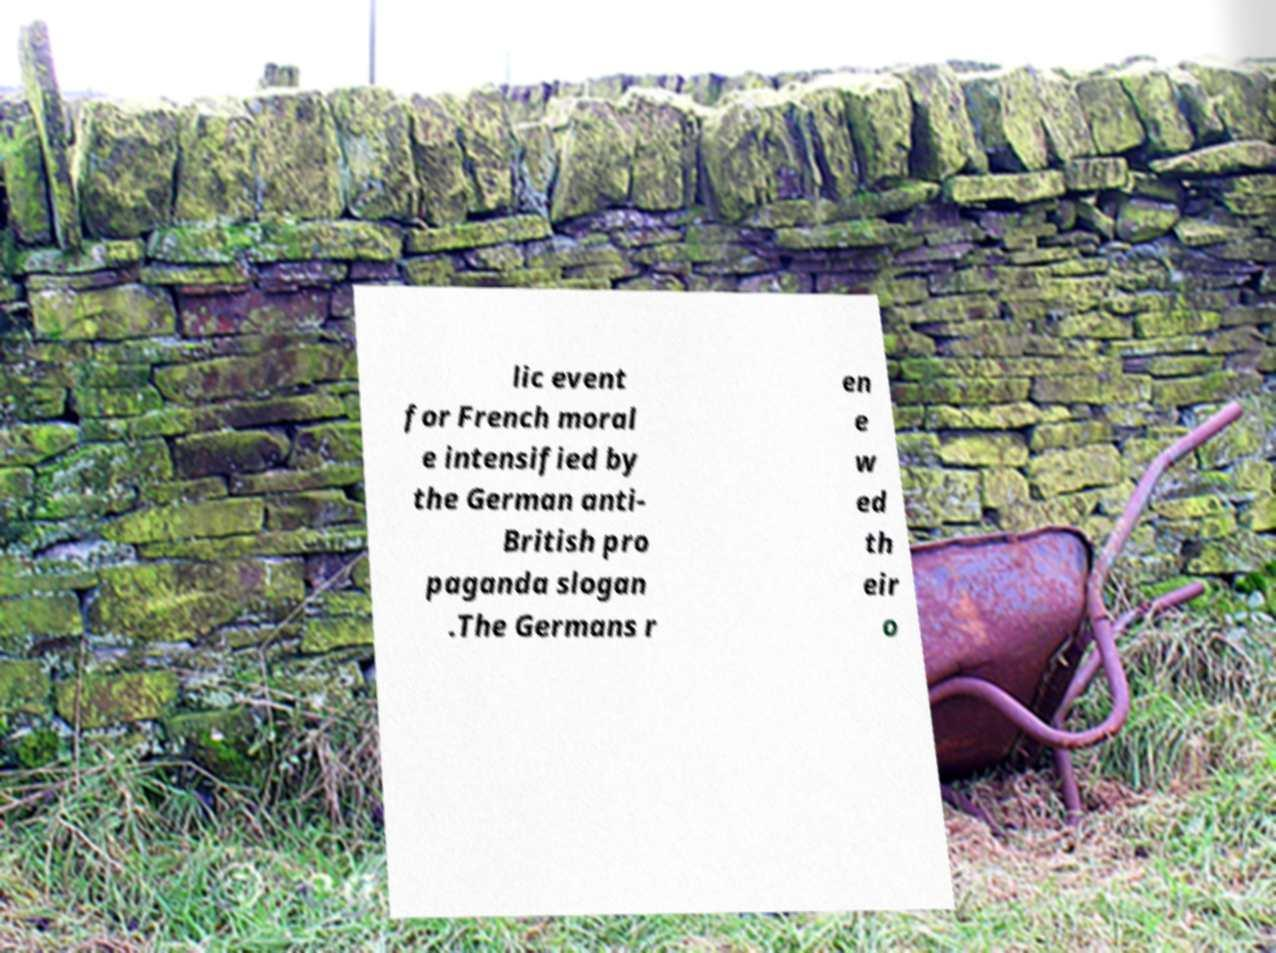Please read and relay the text visible in this image. What does it say? lic event for French moral e intensified by the German anti- British pro paganda slogan .The Germans r en e w ed th eir o 